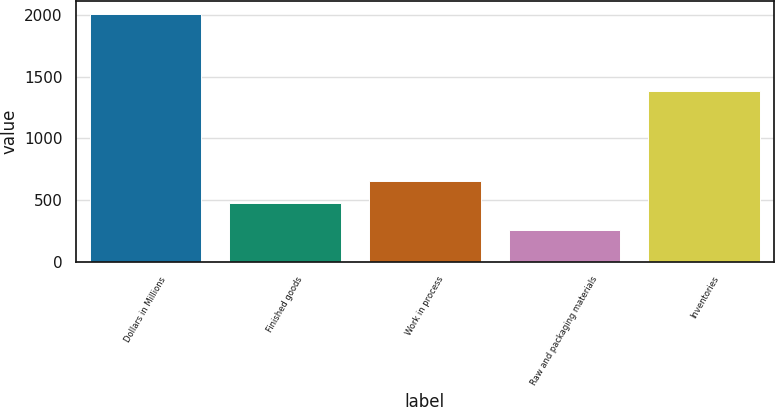Convert chart. <chart><loc_0><loc_0><loc_500><loc_500><bar_chart><fcel>Dollars in Millions<fcel>Finished goods<fcel>Work in process<fcel>Raw and packaging materials<fcel>Inventories<nl><fcel>2011<fcel>478<fcel>653.1<fcel>260<fcel>1384<nl></chart> 